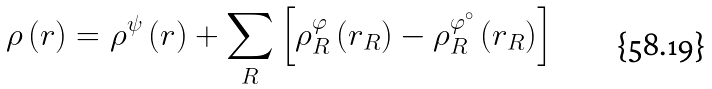Convert formula to latex. <formula><loc_0><loc_0><loc_500><loc_500>\rho \left ( r \right ) = \rho ^ { \psi } \left ( r \right ) + \sum _ { R } \left [ \rho _ { R } ^ { \varphi } \left ( r _ { R } \right ) - \rho _ { R } ^ { \varphi ^ { \circ } } \left ( r _ { R } \right ) \right ]</formula> 